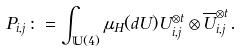<formula> <loc_0><loc_0><loc_500><loc_500>P _ { i , j } \colon = \int _ { \mathbb { U } ( 4 ) } \mu _ { H } ( d U ) U _ { i , j } ^ { \otimes t } \otimes \overline { U } _ { i , j } ^ { \otimes t } .</formula> 